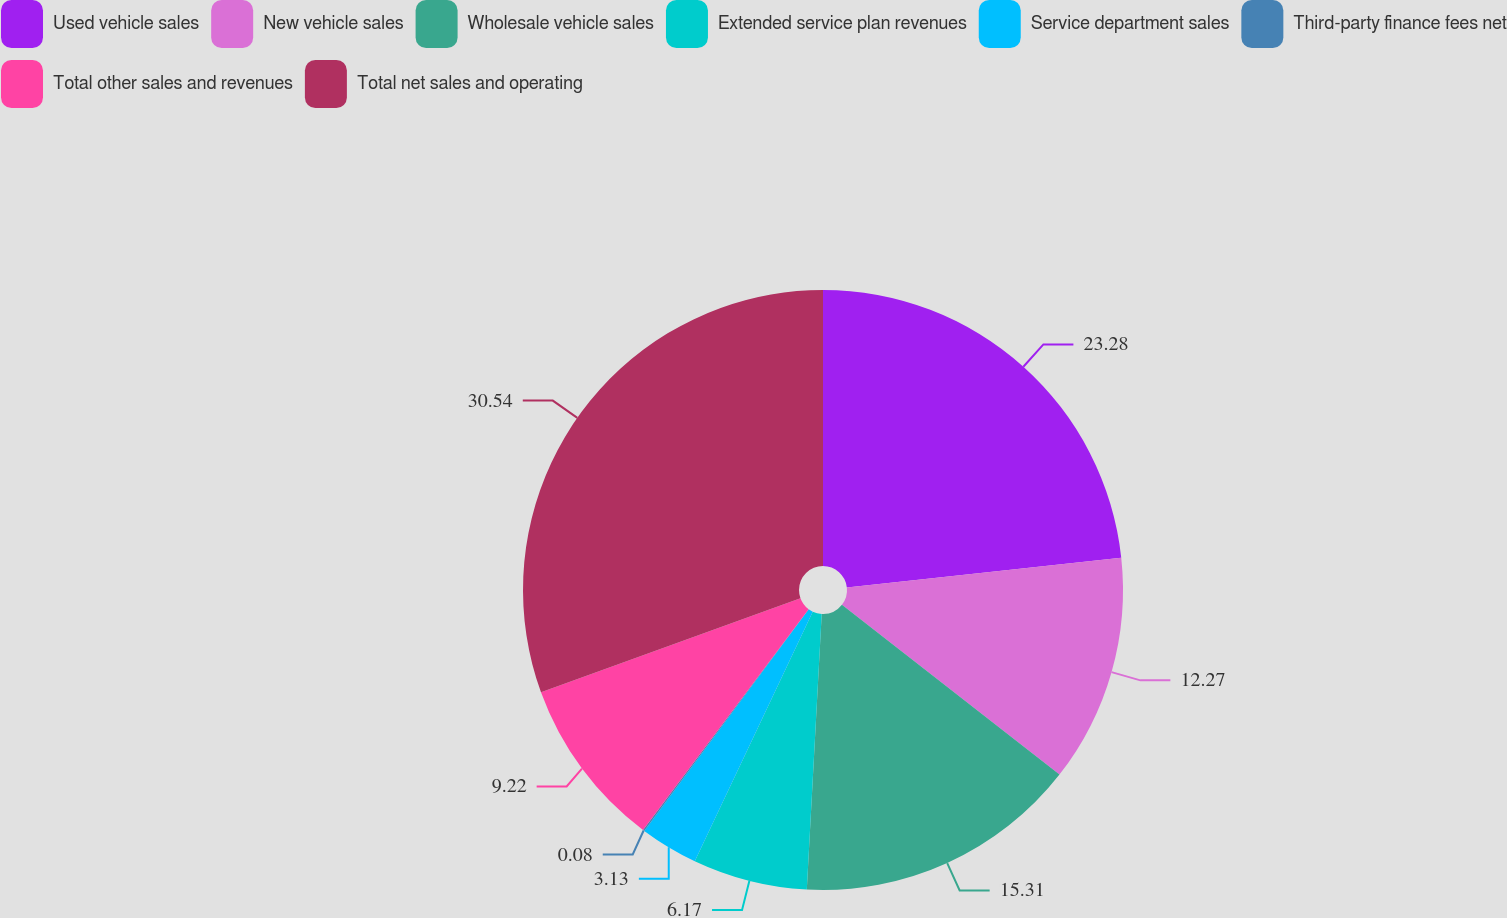Convert chart to OTSL. <chart><loc_0><loc_0><loc_500><loc_500><pie_chart><fcel>Used vehicle sales<fcel>New vehicle sales<fcel>Wholesale vehicle sales<fcel>Extended service plan revenues<fcel>Service department sales<fcel>Third-party finance fees net<fcel>Total other sales and revenues<fcel>Total net sales and operating<nl><fcel>23.28%<fcel>12.27%<fcel>15.31%<fcel>6.17%<fcel>3.13%<fcel>0.08%<fcel>9.22%<fcel>30.54%<nl></chart> 